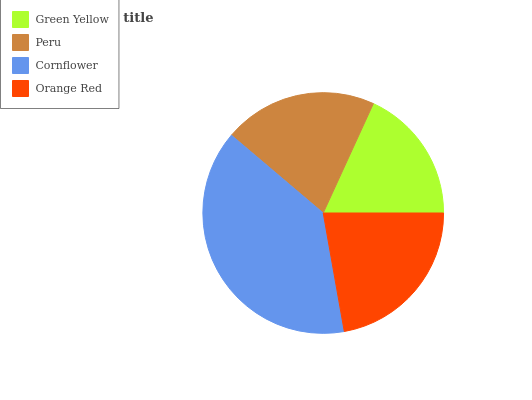Is Green Yellow the minimum?
Answer yes or no. Yes. Is Cornflower the maximum?
Answer yes or no. Yes. Is Peru the minimum?
Answer yes or no. No. Is Peru the maximum?
Answer yes or no. No. Is Peru greater than Green Yellow?
Answer yes or no. Yes. Is Green Yellow less than Peru?
Answer yes or no. Yes. Is Green Yellow greater than Peru?
Answer yes or no. No. Is Peru less than Green Yellow?
Answer yes or no. No. Is Orange Red the high median?
Answer yes or no. Yes. Is Peru the low median?
Answer yes or no. Yes. Is Cornflower the high median?
Answer yes or no. No. Is Cornflower the low median?
Answer yes or no. No. 